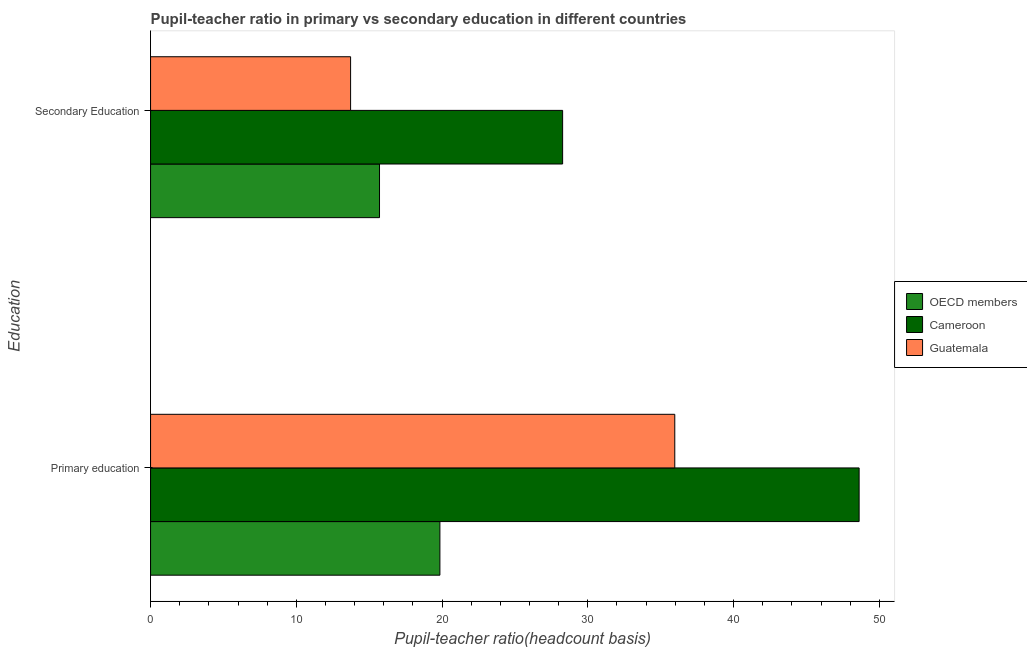How many different coloured bars are there?
Provide a succinct answer. 3. How many groups of bars are there?
Offer a terse response. 2. Are the number of bars on each tick of the Y-axis equal?
Your answer should be very brief. Yes. How many bars are there on the 2nd tick from the top?
Provide a short and direct response. 3. What is the label of the 1st group of bars from the top?
Provide a short and direct response. Secondary Education. What is the pupil teacher ratio on secondary education in OECD members?
Offer a terse response. 15.71. Across all countries, what is the maximum pupil teacher ratio on secondary education?
Provide a short and direct response. 28.27. Across all countries, what is the minimum pupil teacher ratio on secondary education?
Make the answer very short. 13.72. In which country was the pupil-teacher ratio in primary education maximum?
Give a very brief answer. Cameroon. What is the total pupil teacher ratio on secondary education in the graph?
Your answer should be very brief. 57.7. What is the difference between the pupil teacher ratio on secondary education in Cameroon and that in OECD members?
Provide a succinct answer. 12.56. What is the difference between the pupil teacher ratio on secondary education in OECD members and the pupil-teacher ratio in primary education in Cameroon?
Your answer should be compact. -32.91. What is the average pupil teacher ratio on secondary education per country?
Make the answer very short. 19.23. What is the difference between the pupil-teacher ratio in primary education and pupil teacher ratio on secondary education in OECD members?
Ensure brevity in your answer.  4.14. What is the ratio of the pupil-teacher ratio in primary education in Guatemala to that in Cameroon?
Keep it short and to the point. 0.74. What does the 1st bar from the top in Primary education represents?
Offer a terse response. Guatemala. What does the 3rd bar from the bottom in Secondary Education represents?
Offer a terse response. Guatemala. How many bars are there?
Offer a terse response. 6. Are all the bars in the graph horizontal?
Offer a very short reply. Yes. What is the difference between two consecutive major ticks on the X-axis?
Offer a very short reply. 10. Does the graph contain grids?
Offer a very short reply. No. Where does the legend appear in the graph?
Provide a short and direct response. Center right. How are the legend labels stacked?
Provide a short and direct response. Vertical. What is the title of the graph?
Offer a very short reply. Pupil-teacher ratio in primary vs secondary education in different countries. What is the label or title of the X-axis?
Keep it short and to the point. Pupil-teacher ratio(headcount basis). What is the label or title of the Y-axis?
Give a very brief answer. Education. What is the Pupil-teacher ratio(headcount basis) in OECD members in Primary education?
Your response must be concise. 19.85. What is the Pupil-teacher ratio(headcount basis) of Cameroon in Primary education?
Make the answer very short. 48.61. What is the Pupil-teacher ratio(headcount basis) of Guatemala in Primary education?
Give a very brief answer. 35.97. What is the Pupil-teacher ratio(headcount basis) of OECD members in Secondary Education?
Your answer should be very brief. 15.71. What is the Pupil-teacher ratio(headcount basis) in Cameroon in Secondary Education?
Keep it short and to the point. 28.27. What is the Pupil-teacher ratio(headcount basis) of Guatemala in Secondary Education?
Give a very brief answer. 13.72. Across all Education, what is the maximum Pupil-teacher ratio(headcount basis) in OECD members?
Provide a short and direct response. 19.85. Across all Education, what is the maximum Pupil-teacher ratio(headcount basis) of Cameroon?
Your response must be concise. 48.61. Across all Education, what is the maximum Pupil-teacher ratio(headcount basis) of Guatemala?
Offer a terse response. 35.97. Across all Education, what is the minimum Pupil-teacher ratio(headcount basis) of OECD members?
Provide a succinct answer. 15.71. Across all Education, what is the minimum Pupil-teacher ratio(headcount basis) in Cameroon?
Provide a succinct answer. 28.27. Across all Education, what is the minimum Pupil-teacher ratio(headcount basis) of Guatemala?
Provide a short and direct response. 13.72. What is the total Pupil-teacher ratio(headcount basis) in OECD members in the graph?
Provide a succinct answer. 35.56. What is the total Pupil-teacher ratio(headcount basis) of Cameroon in the graph?
Offer a very short reply. 76.88. What is the total Pupil-teacher ratio(headcount basis) in Guatemala in the graph?
Your response must be concise. 49.69. What is the difference between the Pupil-teacher ratio(headcount basis) in OECD members in Primary education and that in Secondary Education?
Your response must be concise. 4.14. What is the difference between the Pupil-teacher ratio(headcount basis) of Cameroon in Primary education and that in Secondary Education?
Give a very brief answer. 20.34. What is the difference between the Pupil-teacher ratio(headcount basis) in Guatemala in Primary education and that in Secondary Education?
Ensure brevity in your answer.  22.24. What is the difference between the Pupil-teacher ratio(headcount basis) in OECD members in Primary education and the Pupil-teacher ratio(headcount basis) in Cameroon in Secondary Education?
Your response must be concise. -8.42. What is the difference between the Pupil-teacher ratio(headcount basis) in OECD members in Primary education and the Pupil-teacher ratio(headcount basis) in Guatemala in Secondary Education?
Provide a succinct answer. 6.13. What is the difference between the Pupil-teacher ratio(headcount basis) of Cameroon in Primary education and the Pupil-teacher ratio(headcount basis) of Guatemala in Secondary Education?
Offer a terse response. 34.89. What is the average Pupil-teacher ratio(headcount basis) of OECD members per Education?
Provide a short and direct response. 17.78. What is the average Pupil-teacher ratio(headcount basis) in Cameroon per Education?
Make the answer very short. 38.44. What is the average Pupil-teacher ratio(headcount basis) in Guatemala per Education?
Your answer should be compact. 24.84. What is the difference between the Pupil-teacher ratio(headcount basis) in OECD members and Pupil-teacher ratio(headcount basis) in Cameroon in Primary education?
Keep it short and to the point. -28.76. What is the difference between the Pupil-teacher ratio(headcount basis) in OECD members and Pupil-teacher ratio(headcount basis) in Guatemala in Primary education?
Ensure brevity in your answer.  -16.11. What is the difference between the Pupil-teacher ratio(headcount basis) of Cameroon and Pupil-teacher ratio(headcount basis) of Guatemala in Primary education?
Your answer should be very brief. 12.65. What is the difference between the Pupil-teacher ratio(headcount basis) in OECD members and Pupil-teacher ratio(headcount basis) in Cameroon in Secondary Education?
Your answer should be compact. -12.56. What is the difference between the Pupil-teacher ratio(headcount basis) in OECD members and Pupil-teacher ratio(headcount basis) in Guatemala in Secondary Education?
Ensure brevity in your answer.  1.98. What is the difference between the Pupil-teacher ratio(headcount basis) of Cameroon and Pupil-teacher ratio(headcount basis) of Guatemala in Secondary Education?
Provide a short and direct response. 14.55. What is the ratio of the Pupil-teacher ratio(headcount basis) in OECD members in Primary education to that in Secondary Education?
Your answer should be very brief. 1.26. What is the ratio of the Pupil-teacher ratio(headcount basis) in Cameroon in Primary education to that in Secondary Education?
Your answer should be very brief. 1.72. What is the ratio of the Pupil-teacher ratio(headcount basis) in Guatemala in Primary education to that in Secondary Education?
Offer a terse response. 2.62. What is the difference between the highest and the second highest Pupil-teacher ratio(headcount basis) in OECD members?
Offer a terse response. 4.14. What is the difference between the highest and the second highest Pupil-teacher ratio(headcount basis) in Cameroon?
Your answer should be very brief. 20.34. What is the difference between the highest and the second highest Pupil-teacher ratio(headcount basis) of Guatemala?
Keep it short and to the point. 22.24. What is the difference between the highest and the lowest Pupil-teacher ratio(headcount basis) of OECD members?
Offer a very short reply. 4.14. What is the difference between the highest and the lowest Pupil-teacher ratio(headcount basis) of Cameroon?
Offer a terse response. 20.34. What is the difference between the highest and the lowest Pupil-teacher ratio(headcount basis) in Guatemala?
Ensure brevity in your answer.  22.24. 